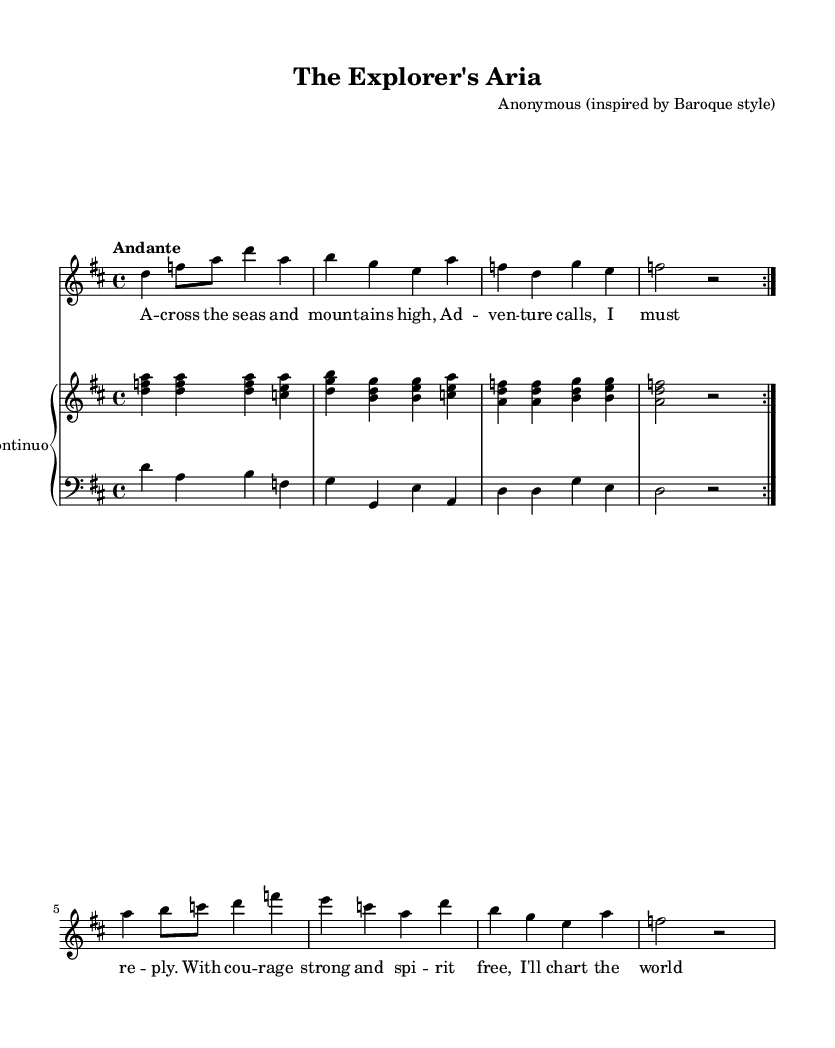What is the key signature of this music? The key signature indicated at the beginning of the score shows two sharps, which corresponds to D major.
Answer: D major What is the time signature of this music? The time signature is written as 4/4, indicating there are four beats in each measure and the quarter note gets one beat.
Answer: 4/4 What is the tempo marking of this piece? The tempo marking in the score is indicated as "Andante," which suggests a moderate walking pace for the piece.
Answer: Andante How many measures are repeated in the soprano part? The score indicates that the soprano part has a "volta" indicating a repeated section; thus, there are two measures that are repeated.
Answer: 2 What instrument is specified for the right hand in the continuo? The instrument for the right hand part is labeled as "harpsichord," which is typical for Baroque continuo music, providing harmonic support.
Answer: Harpsichord What is the theme of the lyrics sung in the soprano part? The lyrics describe themes of adventure and exploration, reflecting the spirit of discovery, akin to Richard Garriott's explorations.
Answer: Adventure and exploration How does the accompaniment of the left hand enhance the piece? The left hand accompaniment features a bass line that supports the harmony and reinforces the emotional depth of the soprano melody, typical in Baroque style.
Answer: Supports harmony 